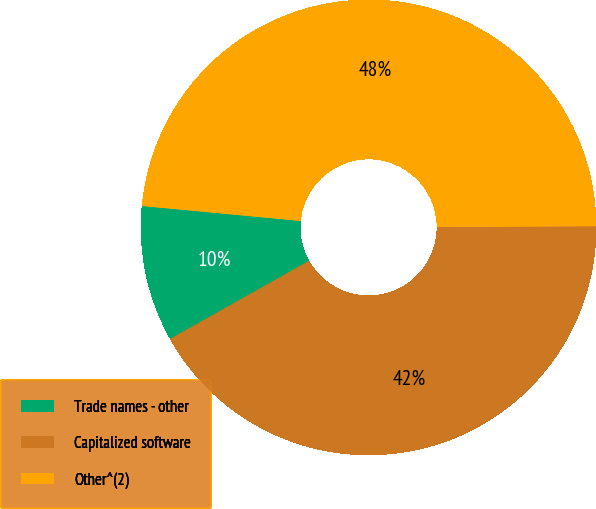<chart> <loc_0><loc_0><loc_500><loc_500><pie_chart><fcel>Trade names - other<fcel>Capitalized software<fcel>Other^(2)<nl><fcel>9.65%<fcel>41.93%<fcel>48.42%<nl></chart> 